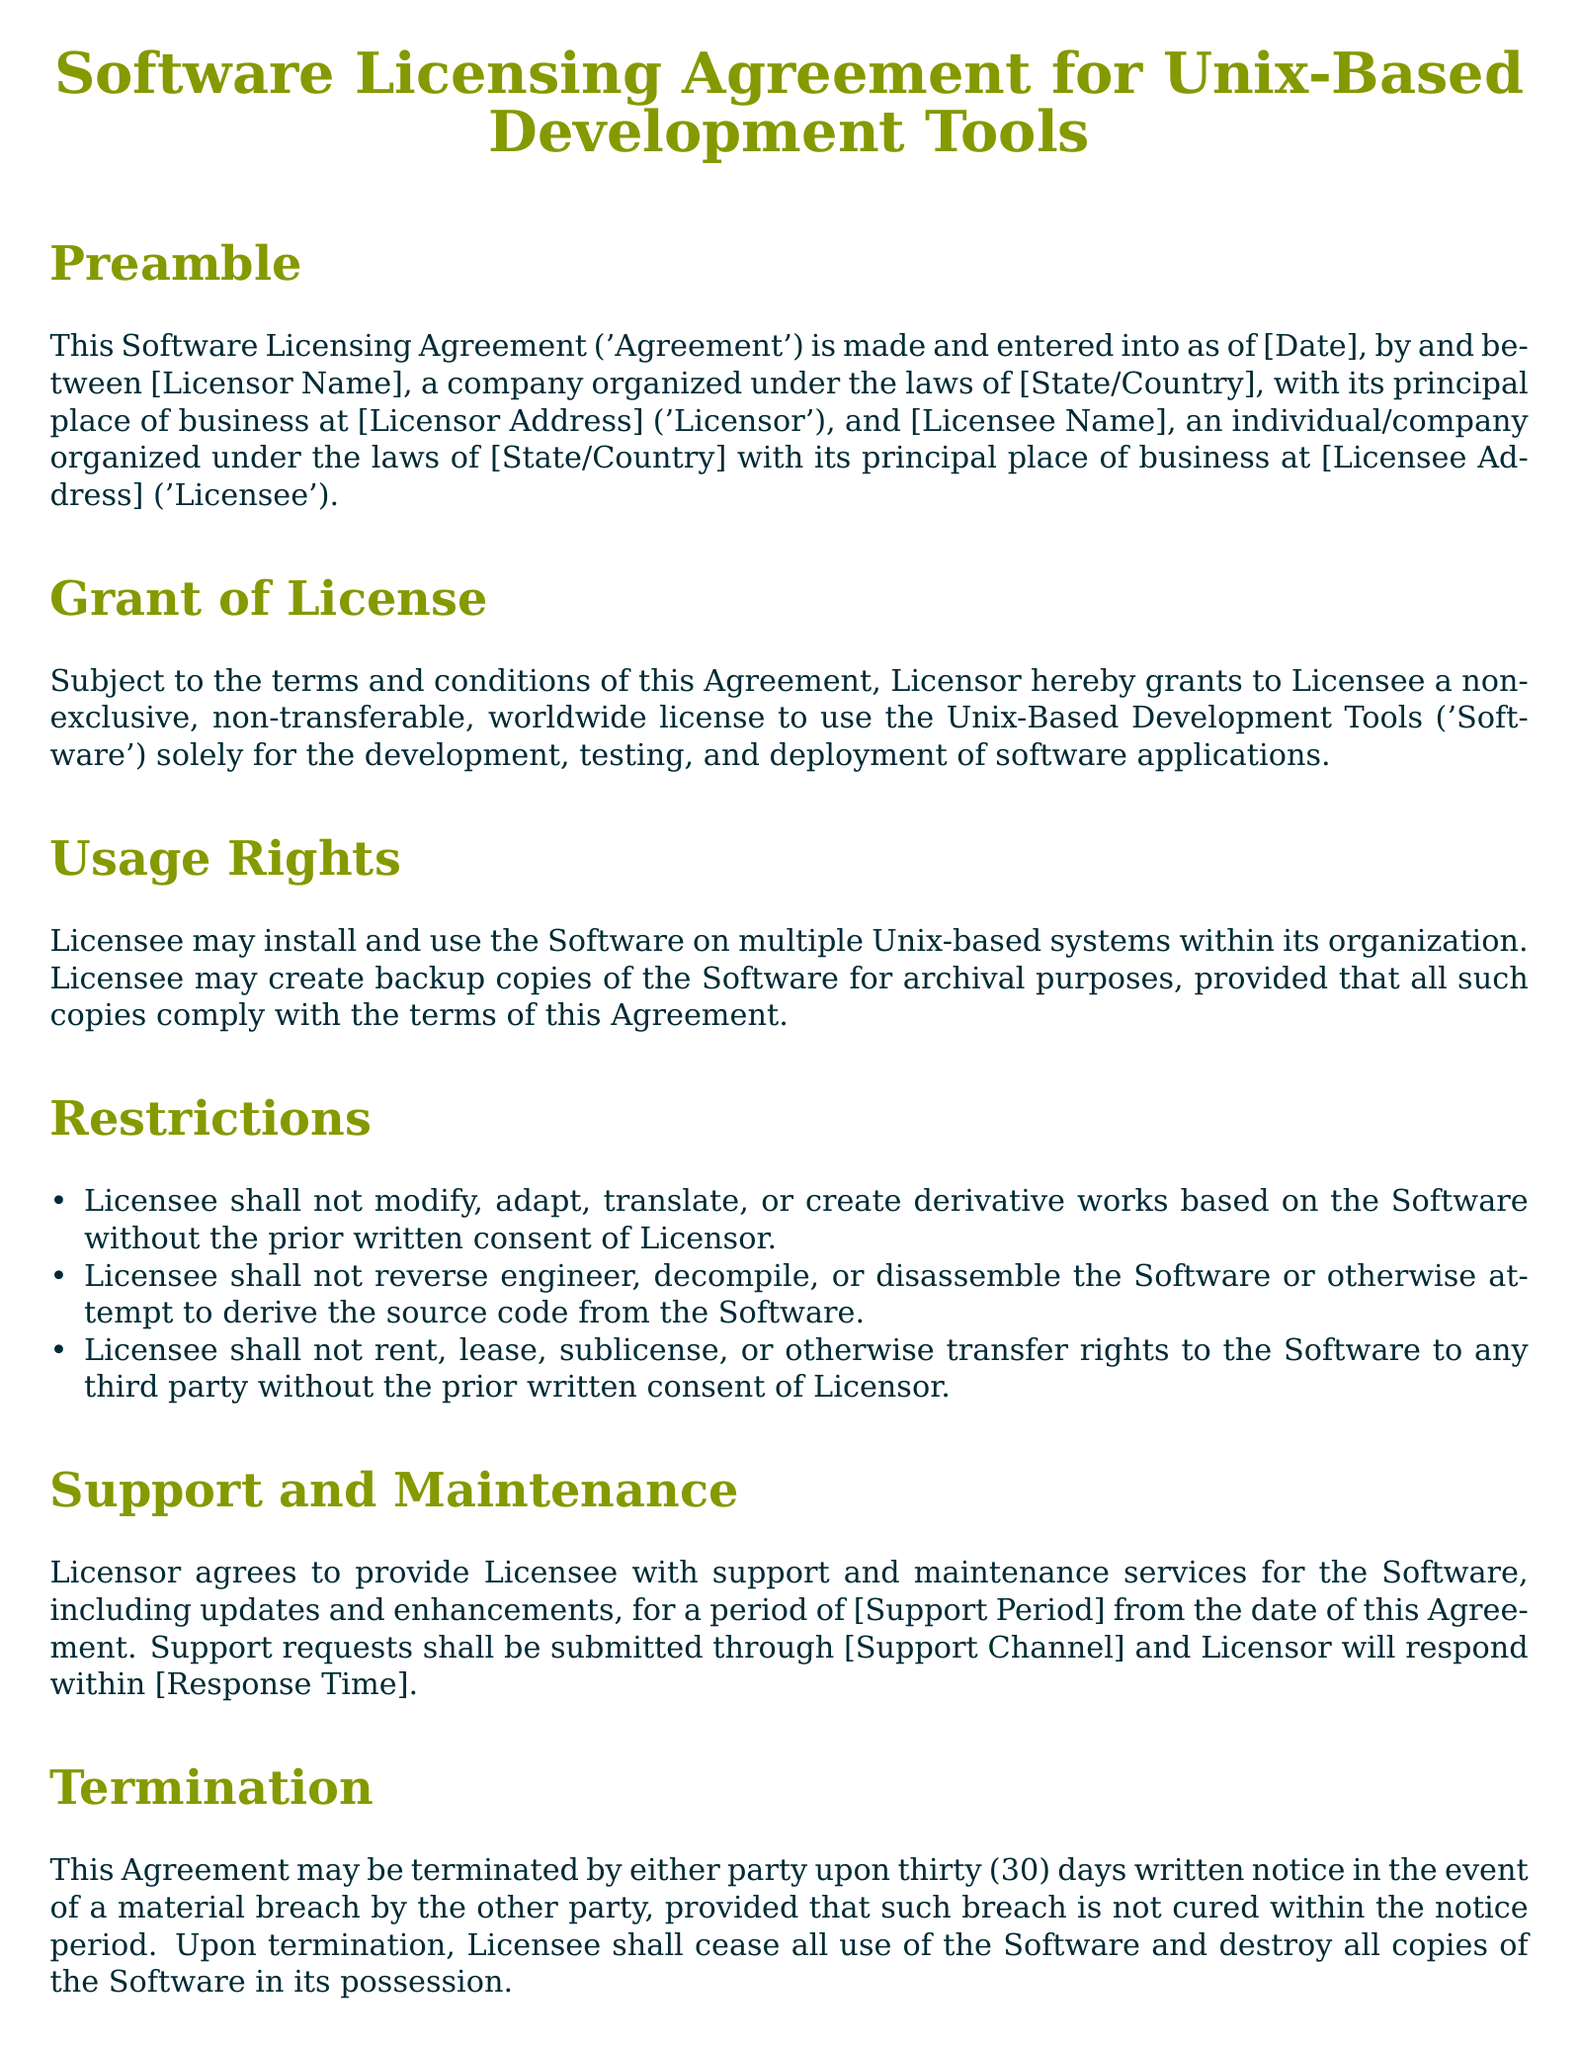What type of license is granted? The document specifies a non-exclusive, non-transferable, worldwide license for the Software.
Answer: non-exclusive, non-transferable, worldwide license How long is the support period? The exact duration for support is mentioned as [Support Period].
Answer: [Support Period] What must a Licensee do with the Software upon termination? According to the document, the Licensee must cease all use and destroy all copies of the Software.
Answer: cease all use and destroy all copies What is the Licensee's right regarding backup copies? The document states that the Licensee may create backup copies for archival purposes.
Answer: create backup copies What action can Licensor take in case of a material breach? The Licensor can terminate the Agreement upon thirty days written notice if a material breach is not cured.
Answer: terminate the Agreement What is prohibited regarding derivative works? The Licensee is not allowed to modify, adapt, translate, or create derivative works without consent.
Answer: not modify, adapt, translate, or create derivative works What governing laws apply to this Agreement? The document specifies that the Agreement is governed by the laws of [State/Country].
Answer: [State/Country] What is not included in Licensor's liability? The document states Licensor is not liable for indirect or consequential damages.
Answer: indirect or consequential damages 